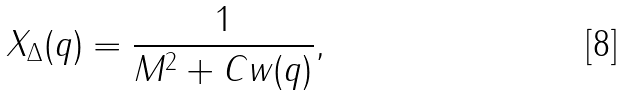Convert formula to latex. <formula><loc_0><loc_0><loc_500><loc_500>X _ { \Delta } ( { q } ) = \frac { 1 } { M ^ { 2 } + C w ( { q } ) } ,</formula> 